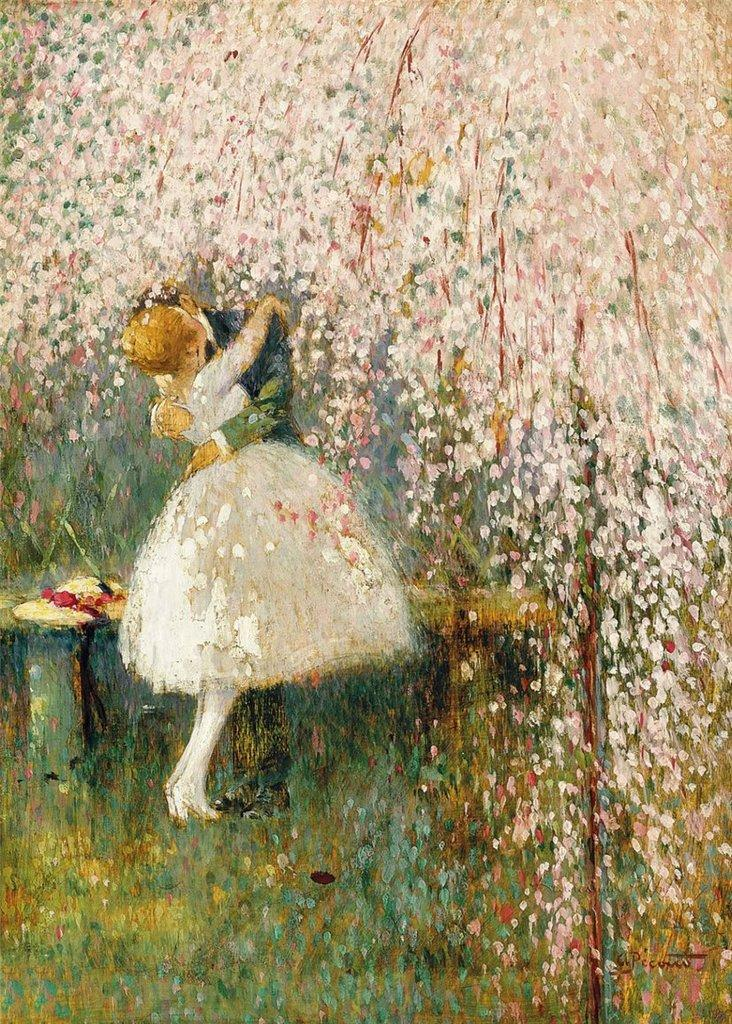What is the main subject of the image? The main subject of the image is an art piece. What does the art piece depict? The art piece depicts persons. What type of quince is being used as a prop in the art piece? There is no quince present in the image, as the art piece depicts persons and does not mention any fruit. 